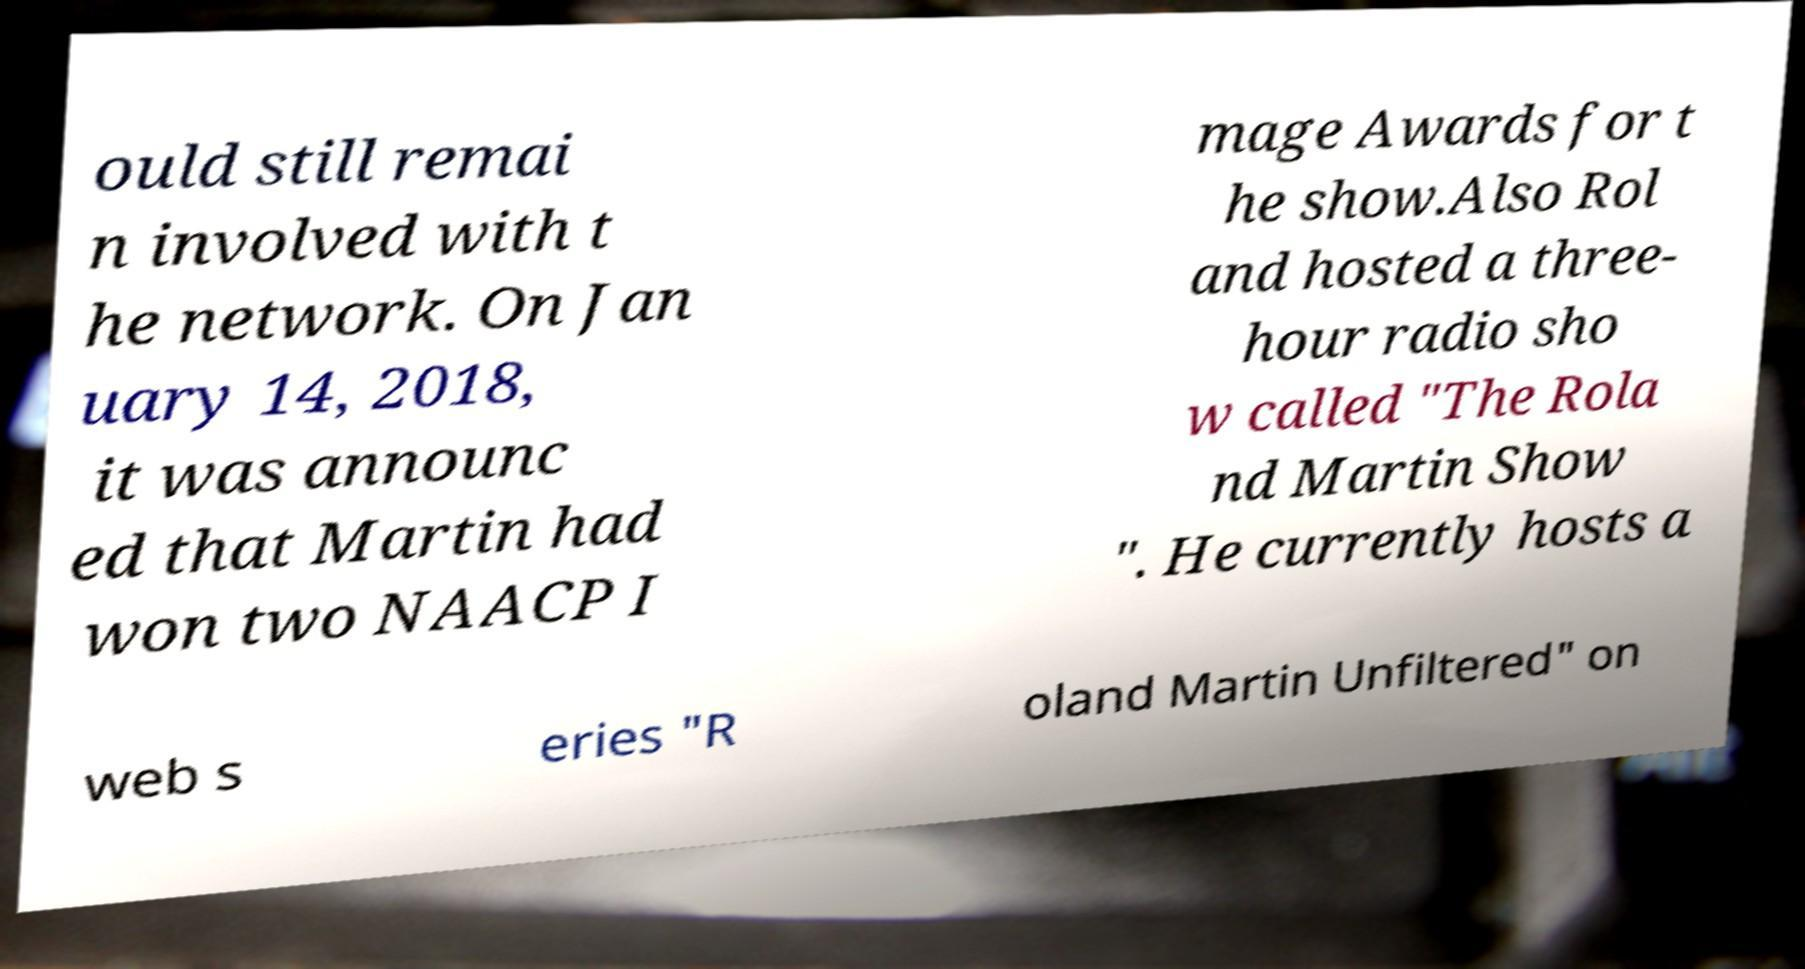There's text embedded in this image that I need extracted. Can you transcribe it verbatim? ould still remai n involved with t he network. On Jan uary 14, 2018, it was announc ed that Martin had won two NAACP I mage Awards for t he show.Also Rol and hosted a three- hour radio sho w called "The Rola nd Martin Show ". He currently hosts a web s eries "R oland Martin Unfiltered" on 